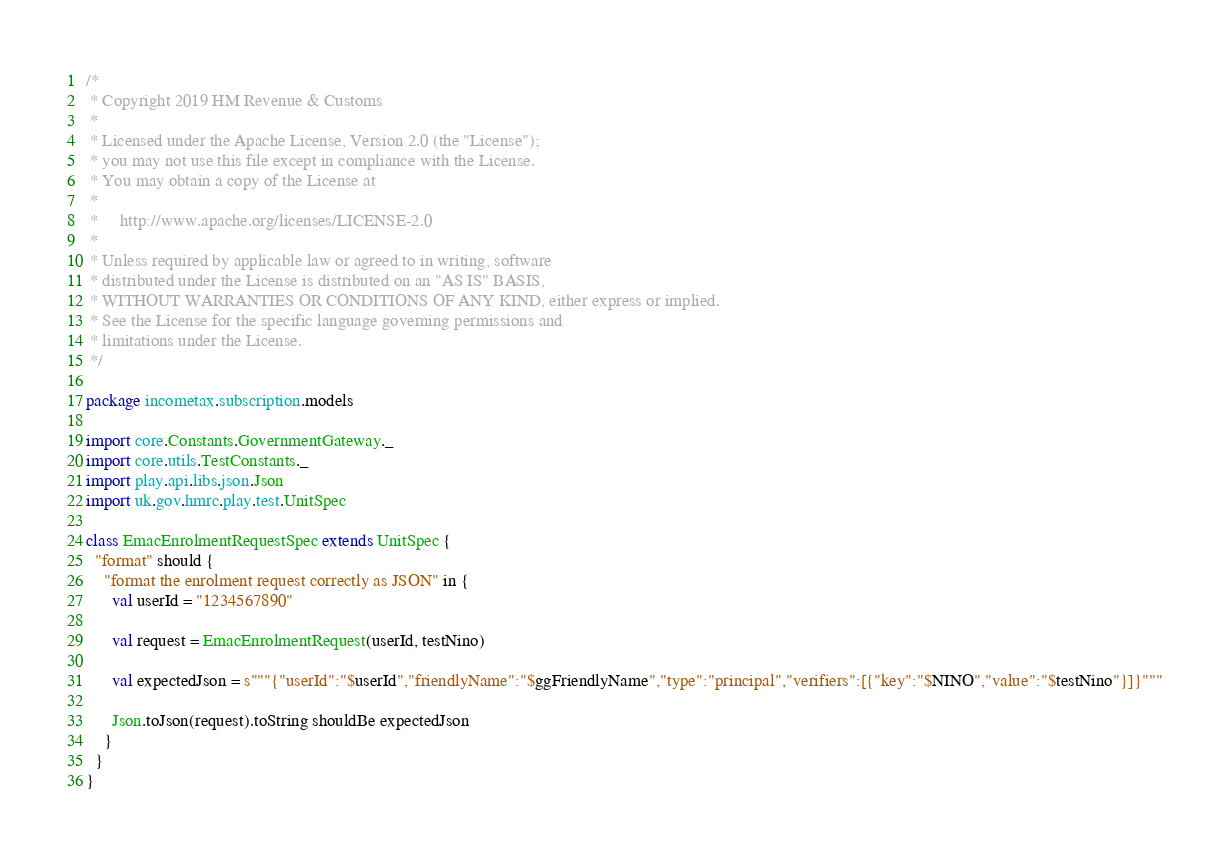Convert code to text. <code><loc_0><loc_0><loc_500><loc_500><_Scala_>/*
 * Copyright 2019 HM Revenue & Customs
 *
 * Licensed under the Apache License, Version 2.0 (the "License");
 * you may not use this file except in compliance with the License.
 * You may obtain a copy of the License at
 *
 *     http://www.apache.org/licenses/LICENSE-2.0
 *
 * Unless required by applicable law or agreed to in writing, software
 * distributed under the License is distributed on an "AS IS" BASIS,
 * WITHOUT WARRANTIES OR CONDITIONS OF ANY KIND, either express or implied.
 * See the License for the specific language governing permissions and
 * limitations under the License.
 */

package incometax.subscription.models

import core.Constants.GovernmentGateway._
import core.utils.TestConstants._
import play.api.libs.json.Json
import uk.gov.hmrc.play.test.UnitSpec

class EmacEnrolmentRequestSpec extends UnitSpec {
  "format" should {
    "format the enrolment request correctly as JSON" in {
      val userId = "1234567890"

      val request = EmacEnrolmentRequest(userId, testNino)

      val expectedJson = s"""{"userId":"$userId","friendlyName":"$ggFriendlyName","type":"principal","verifiers":[{"key":"$NINO","value":"$testNino"}]}"""

      Json.toJson(request).toString shouldBe expectedJson
    }
  }
}
</code> 